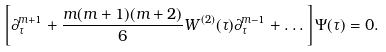<formula> <loc_0><loc_0><loc_500><loc_500>\left [ \partial _ { \tau } ^ { m + 1 } + \frac { m ( m + 1 ) ( m + 2 ) } { 6 } W ^ { ( 2 ) } ( \tau ) \partial _ { \tau } ^ { m - 1 } + \dots \right ] \Psi ( \tau ) = 0 .</formula> 